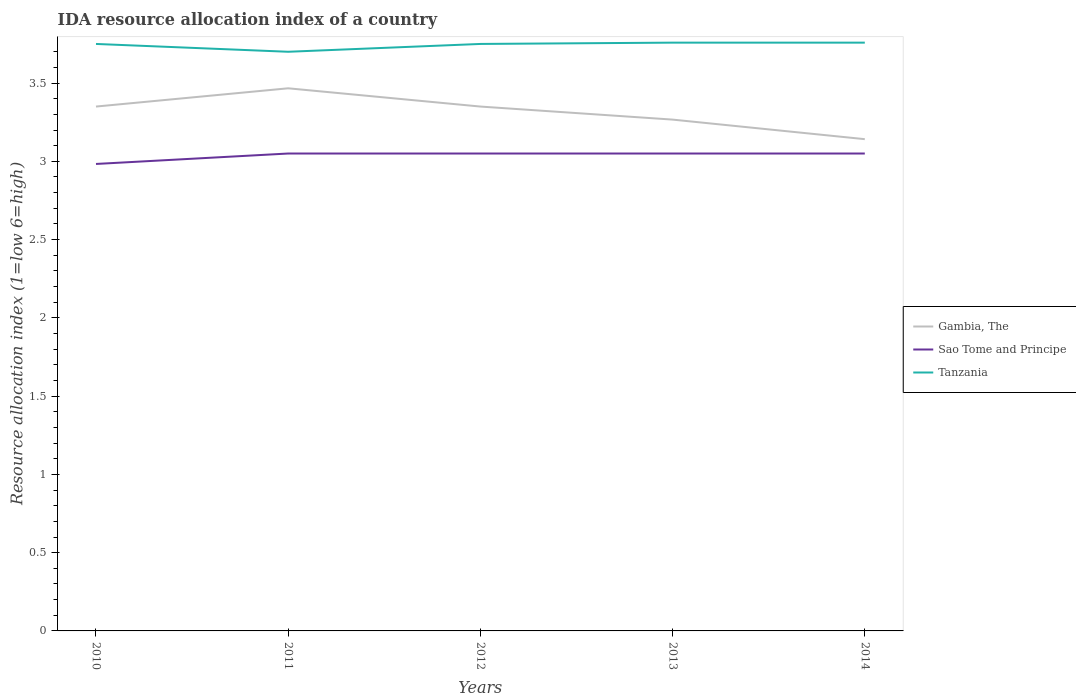How many different coloured lines are there?
Give a very brief answer. 3. Does the line corresponding to Tanzania intersect with the line corresponding to Gambia, The?
Your response must be concise. No. Is the number of lines equal to the number of legend labels?
Your answer should be compact. Yes. Across all years, what is the maximum IDA resource allocation index in Sao Tome and Principe?
Make the answer very short. 2.98. What is the total IDA resource allocation index in Sao Tome and Principe in the graph?
Ensure brevity in your answer.  -0.07. What is the difference between the highest and the second highest IDA resource allocation index in Sao Tome and Principe?
Provide a succinct answer. 0.07. How many years are there in the graph?
Offer a terse response. 5. Are the values on the major ticks of Y-axis written in scientific E-notation?
Your answer should be very brief. No. Does the graph contain any zero values?
Your answer should be very brief. No. Does the graph contain grids?
Give a very brief answer. No. Where does the legend appear in the graph?
Offer a terse response. Center right. How are the legend labels stacked?
Give a very brief answer. Vertical. What is the title of the graph?
Ensure brevity in your answer.  IDA resource allocation index of a country. Does "South Africa" appear as one of the legend labels in the graph?
Your response must be concise. No. What is the label or title of the X-axis?
Your answer should be compact. Years. What is the label or title of the Y-axis?
Offer a terse response. Resource allocation index (1=low 6=high). What is the Resource allocation index (1=low 6=high) in Gambia, The in 2010?
Give a very brief answer. 3.35. What is the Resource allocation index (1=low 6=high) in Sao Tome and Principe in 2010?
Give a very brief answer. 2.98. What is the Resource allocation index (1=low 6=high) in Tanzania in 2010?
Offer a very short reply. 3.75. What is the Resource allocation index (1=low 6=high) in Gambia, The in 2011?
Your answer should be very brief. 3.47. What is the Resource allocation index (1=low 6=high) in Sao Tome and Principe in 2011?
Your response must be concise. 3.05. What is the Resource allocation index (1=low 6=high) in Gambia, The in 2012?
Offer a very short reply. 3.35. What is the Resource allocation index (1=low 6=high) of Sao Tome and Principe in 2012?
Your answer should be very brief. 3.05. What is the Resource allocation index (1=low 6=high) of Tanzania in 2012?
Make the answer very short. 3.75. What is the Resource allocation index (1=low 6=high) of Gambia, The in 2013?
Your answer should be very brief. 3.27. What is the Resource allocation index (1=low 6=high) in Sao Tome and Principe in 2013?
Your response must be concise. 3.05. What is the Resource allocation index (1=low 6=high) of Tanzania in 2013?
Keep it short and to the point. 3.76. What is the Resource allocation index (1=low 6=high) of Gambia, The in 2014?
Your answer should be compact. 3.14. What is the Resource allocation index (1=low 6=high) in Sao Tome and Principe in 2014?
Keep it short and to the point. 3.05. What is the Resource allocation index (1=low 6=high) of Tanzania in 2014?
Give a very brief answer. 3.76. Across all years, what is the maximum Resource allocation index (1=low 6=high) of Gambia, The?
Offer a very short reply. 3.47. Across all years, what is the maximum Resource allocation index (1=low 6=high) of Sao Tome and Principe?
Ensure brevity in your answer.  3.05. Across all years, what is the maximum Resource allocation index (1=low 6=high) in Tanzania?
Your response must be concise. 3.76. Across all years, what is the minimum Resource allocation index (1=low 6=high) of Gambia, The?
Your answer should be very brief. 3.14. Across all years, what is the minimum Resource allocation index (1=low 6=high) in Sao Tome and Principe?
Provide a short and direct response. 2.98. Across all years, what is the minimum Resource allocation index (1=low 6=high) of Tanzania?
Offer a very short reply. 3.7. What is the total Resource allocation index (1=low 6=high) of Gambia, The in the graph?
Your response must be concise. 16.57. What is the total Resource allocation index (1=low 6=high) in Sao Tome and Principe in the graph?
Provide a succinct answer. 15.18. What is the total Resource allocation index (1=low 6=high) in Tanzania in the graph?
Your answer should be compact. 18.72. What is the difference between the Resource allocation index (1=low 6=high) in Gambia, The in 2010 and that in 2011?
Give a very brief answer. -0.12. What is the difference between the Resource allocation index (1=low 6=high) of Sao Tome and Principe in 2010 and that in 2011?
Offer a very short reply. -0.07. What is the difference between the Resource allocation index (1=low 6=high) of Tanzania in 2010 and that in 2011?
Your answer should be compact. 0.05. What is the difference between the Resource allocation index (1=low 6=high) of Gambia, The in 2010 and that in 2012?
Provide a short and direct response. 0. What is the difference between the Resource allocation index (1=low 6=high) of Sao Tome and Principe in 2010 and that in 2012?
Offer a terse response. -0.07. What is the difference between the Resource allocation index (1=low 6=high) in Tanzania in 2010 and that in 2012?
Offer a terse response. 0. What is the difference between the Resource allocation index (1=low 6=high) of Gambia, The in 2010 and that in 2013?
Ensure brevity in your answer.  0.08. What is the difference between the Resource allocation index (1=low 6=high) in Sao Tome and Principe in 2010 and that in 2013?
Your answer should be compact. -0.07. What is the difference between the Resource allocation index (1=low 6=high) of Tanzania in 2010 and that in 2013?
Your answer should be compact. -0.01. What is the difference between the Resource allocation index (1=low 6=high) of Gambia, The in 2010 and that in 2014?
Provide a succinct answer. 0.21. What is the difference between the Resource allocation index (1=low 6=high) of Sao Tome and Principe in 2010 and that in 2014?
Provide a short and direct response. -0.07. What is the difference between the Resource allocation index (1=low 6=high) of Tanzania in 2010 and that in 2014?
Your answer should be compact. -0.01. What is the difference between the Resource allocation index (1=low 6=high) of Gambia, The in 2011 and that in 2012?
Ensure brevity in your answer.  0.12. What is the difference between the Resource allocation index (1=low 6=high) in Tanzania in 2011 and that in 2012?
Ensure brevity in your answer.  -0.05. What is the difference between the Resource allocation index (1=low 6=high) of Gambia, The in 2011 and that in 2013?
Your answer should be compact. 0.2. What is the difference between the Resource allocation index (1=low 6=high) of Tanzania in 2011 and that in 2013?
Make the answer very short. -0.06. What is the difference between the Resource allocation index (1=low 6=high) in Gambia, The in 2011 and that in 2014?
Your answer should be compact. 0.33. What is the difference between the Resource allocation index (1=low 6=high) of Sao Tome and Principe in 2011 and that in 2014?
Offer a terse response. 0. What is the difference between the Resource allocation index (1=low 6=high) of Tanzania in 2011 and that in 2014?
Provide a succinct answer. -0.06. What is the difference between the Resource allocation index (1=low 6=high) in Gambia, The in 2012 and that in 2013?
Offer a terse response. 0.08. What is the difference between the Resource allocation index (1=low 6=high) of Tanzania in 2012 and that in 2013?
Your answer should be compact. -0.01. What is the difference between the Resource allocation index (1=low 6=high) of Gambia, The in 2012 and that in 2014?
Make the answer very short. 0.21. What is the difference between the Resource allocation index (1=low 6=high) of Tanzania in 2012 and that in 2014?
Offer a very short reply. -0.01. What is the difference between the Resource allocation index (1=low 6=high) of Gambia, The in 2013 and that in 2014?
Offer a terse response. 0.12. What is the difference between the Resource allocation index (1=low 6=high) in Sao Tome and Principe in 2013 and that in 2014?
Make the answer very short. 0. What is the difference between the Resource allocation index (1=low 6=high) in Tanzania in 2013 and that in 2014?
Your answer should be compact. 0. What is the difference between the Resource allocation index (1=low 6=high) of Gambia, The in 2010 and the Resource allocation index (1=low 6=high) of Tanzania in 2011?
Make the answer very short. -0.35. What is the difference between the Resource allocation index (1=low 6=high) of Sao Tome and Principe in 2010 and the Resource allocation index (1=low 6=high) of Tanzania in 2011?
Offer a terse response. -0.72. What is the difference between the Resource allocation index (1=low 6=high) of Sao Tome and Principe in 2010 and the Resource allocation index (1=low 6=high) of Tanzania in 2012?
Provide a short and direct response. -0.77. What is the difference between the Resource allocation index (1=low 6=high) in Gambia, The in 2010 and the Resource allocation index (1=low 6=high) in Tanzania in 2013?
Keep it short and to the point. -0.41. What is the difference between the Resource allocation index (1=low 6=high) of Sao Tome and Principe in 2010 and the Resource allocation index (1=low 6=high) of Tanzania in 2013?
Offer a terse response. -0.78. What is the difference between the Resource allocation index (1=low 6=high) of Gambia, The in 2010 and the Resource allocation index (1=low 6=high) of Tanzania in 2014?
Your answer should be very brief. -0.41. What is the difference between the Resource allocation index (1=low 6=high) in Sao Tome and Principe in 2010 and the Resource allocation index (1=low 6=high) in Tanzania in 2014?
Keep it short and to the point. -0.78. What is the difference between the Resource allocation index (1=low 6=high) of Gambia, The in 2011 and the Resource allocation index (1=low 6=high) of Sao Tome and Principe in 2012?
Provide a succinct answer. 0.42. What is the difference between the Resource allocation index (1=low 6=high) of Gambia, The in 2011 and the Resource allocation index (1=low 6=high) of Tanzania in 2012?
Provide a short and direct response. -0.28. What is the difference between the Resource allocation index (1=low 6=high) of Sao Tome and Principe in 2011 and the Resource allocation index (1=low 6=high) of Tanzania in 2012?
Offer a terse response. -0.7. What is the difference between the Resource allocation index (1=low 6=high) of Gambia, The in 2011 and the Resource allocation index (1=low 6=high) of Sao Tome and Principe in 2013?
Give a very brief answer. 0.42. What is the difference between the Resource allocation index (1=low 6=high) in Gambia, The in 2011 and the Resource allocation index (1=low 6=high) in Tanzania in 2013?
Ensure brevity in your answer.  -0.29. What is the difference between the Resource allocation index (1=low 6=high) in Sao Tome and Principe in 2011 and the Resource allocation index (1=low 6=high) in Tanzania in 2013?
Keep it short and to the point. -0.71. What is the difference between the Resource allocation index (1=low 6=high) of Gambia, The in 2011 and the Resource allocation index (1=low 6=high) of Sao Tome and Principe in 2014?
Your response must be concise. 0.42. What is the difference between the Resource allocation index (1=low 6=high) of Gambia, The in 2011 and the Resource allocation index (1=low 6=high) of Tanzania in 2014?
Keep it short and to the point. -0.29. What is the difference between the Resource allocation index (1=low 6=high) of Sao Tome and Principe in 2011 and the Resource allocation index (1=low 6=high) of Tanzania in 2014?
Provide a succinct answer. -0.71. What is the difference between the Resource allocation index (1=low 6=high) in Gambia, The in 2012 and the Resource allocation index (1=low 6=high) in Tanzania in 2013?
Make the answer very short. -0.41. What is the difference between the Resource allocation index (1=low 6=high) of Sao Tome and Principe in 2012 and the Resource allocation index (1=low 6=high) of Tanzania in 2013?
Your answer should be very brief. -0.71. What is the difference between the Resource allocation index (1=low 6=high) of Gambia, The in 2012 and the Resource allocation index (1=low 6=high) of Tanzania in 2014?
Your answer should be very brief. -0.41. What is the difference between the Resource allocation index (1=low 6=high) in Sao Tome and Principe in 2012 and the Resource allocation index (1=low 6=high) in Tanzania in 2014?
Your answer should be very brief. -0.71. What is the difference between the Resource allocation index (1=low 6=high) of Gambia, The in 2013 and the Resource allocation index (1=low 6=high) of Sao Tome and Principe in 2014?
Your answer should be compact. 0.22. What is the difference between the Resource allocation index (1=low 6=high) of Gambia, The in 2013 and the Resource allocation index (1=low 6=high) of Tanzania in 2014?
Your answer should be very brief. -0.49. What is the difference between the Resource allocation index (1=low 6=high) of Sao Tome and Principe in 2013 and the Resource allocation index (1=low 6=high) of Tanzania in 2014?
Your answer should be compact. -0.71. What is the average Resource allocation index (1=low 6=high) of Gambia, The per year?
Your answer should be compact. 3.31. What is the average Resource allocation index (1=low 6=high) in Sao Tome and Principe per year?
Offer a terse response. 3.04. What is the average Resource allocation index (1=low 6=high) of Tanzania per year?
Offer a very short reply. 3.74. In the year 2010, what is the difference between the Resource allocation index (1=low 6=high) in Gambia, The and Resource allocation index (1=low 6=high) in Sao Tome and Principe?
Provide a succinct answer. 0.37. In the year 2010, what is the difference between the Resource allocation index (1=low 6=high) in Gambia, The and Resource allocation index (1=low 6=high) in Tanzania?
Provide a succinct answer. -0.4. In the year 2010, what is the difference between the Resource allocation index (1=low 6=high) of Sao Tome and Principe and Resource allocation index (1=low 6=high) of Tanzania?
Offer a very short reply. -0.77. In the year 2011, what is the difference between the Resource allocation index (1=low 6=high) in Gambia, The and Resource allocation index (1=low 6=high) in Sao Tome and Principe?
Make the answer very short. 0.42. In the year 2011, what is the difference between the Resource allocation index (1=low 6=high) in Gambia, The and Resource allocation index (1=low 6=high) in Tanzania?
Your response must be concise. -0.23. In the year 2011, what is the difference between the Resource allocation index (1=low 6=high) of Sao Tome and Principe and Resource allocation index (1=low 6=high) of Tanzania?
Offer a very short reply. -0.65. In the year 2012, what is the difference between the Resource allocation index (1=low 6=high) of Gambia, The and Resource allocation index (1=low 6=high) of Tanzania?
Ensure brevity in your answer.  -0.4. In the year 2012, what is the difference between the Resource allocation index (1=low 6=high) of Sao Tome and Principe and Resource allocation index (1=low 6=high) of Tanzania?
Provide a succinct answer. -0.7. In the year 2013, what is the difference between the Resource allocation index (1=low 6=high) in Gambia, The and Resource allocation index (1=low 6=high) in Sao Tome and Principe?
Your response must be concise. 0.22. In the year 2013, what is the difference between the Resource allocation index (1=low 6=high) in Gambia, The and Resource allocation index (1=low 6=high) in Tanzania?
Offer a terse response. -0.49. In the year 2013, what is the difference between the Resource allocation index (1=low 6=high) of Sao Tome and Principe and Resource allocation index (1=low 6=high) of Tanzania?
Your response must be concise. -0.71. In the year 2014, what is the difference between the Resource allocation index (1=low 6=high) of Gambia, The and Resource allocation index (1=low 6=high) of Sao Tome and Principe?
Make the answer very short. 0.09. In the year 2014, what is the difference between the Resource allocation index (1=low 6=high) in Gambia, The and Resource allocation index (1=low 6=high) in Tanzania?
Provide a succinct answer. -0.62. In the year 2014, what is the difference between the Resource allocation index (1=low 6=high) of Sao Tome and Principe and Resource allocation index (1=low 6=high) of Tanzania?
Offer a terse response. -0.71. What is the ratio of the Resource allocation index (1=low 6=high) in Gambia, The in 2010 to that in 2011?
Your response must be concise. 0.97. What is the ratio of the Resource allocation index (1=low 6=high) of Sao Tome and Principe in 2010 to that in 2011?
Your answer should be compact. 0.98. What is the ratio of the Resource allocation index (1=low 6=high) in Tanzania in 2010 to that in 2011?
Offer a terse response. 1.01. What is the ratio of the Resource allocation index (1=low 6=high) of Gambia, The in 2010 to that in 2012?
Your response must be concise. 1. What is the ratio of the Resource allocation index (1=low 6=high) of Sao Tome and Principe in 2010 to that in 2012?
Offer a terse response. 0.98. What is the ratio of the Resource allocation index (1=low 6=high) in Tanzania in 2010 to that in 2012?
Your answer should be compact. 1. What is the ratio of the Resource allocation index (1=low 6=high) of Gambia, The in 2010 to that in 2013?
Give a very brief answer. 1.03. What is the ratio of the Resource allocation index (1=low 6=high) of Sao Tome and Principe in 2010 to that in 2013?
Keep it short and to the point. 0.98. What is the ratio of the Resource allocation index (1=low 6=high) of Gambia, The in 2010 to that in 2014?
Provide a succinct answer. 1.07. What is the ratio of the Resource allocation index (1=low 6=high) in Sao Tome and Principe in 2010 to that in 2014?
Offer a very short reply. 0.98. What is the ratio of the Resource allocation index (1=low 6=high) in Tanzania in 2010 to that in 2014?
Give a very brief answer. 1. What is the ratio of the Resource allocation index (1=low 6=high) in Gambia, The in 2011 to that in 2012?
Give a very brief answer. 1.03. What is the ratio of the Resource allocation index (1=low 6=high) of Sao Tome and Principe in 2011 to that in 2012?
Offer a terse response. 1. What is the ratio of the Resource allocation index (1=low 6=high) in Tanzania in 2011 to that in 2012?
Keep it short and to the point. 0.99. What is the ratio of the Resource allocation index (1=low 6=high) in Gambia, The in 2011 to that in 2013?
Provide a succinct answer. 1.06. What is the ratio of the Resource allocation index (1=low 6=high) of Tanzania in 2011 to that in 2013?
Keep it short and to the point. 0.98. What is the ratio of the Resource allocation index (1=low 6=high) of Gambia, The in 2011 to that in 2014?
Make the answer very short. 1.1. What is the ratio of the Resource allocation index (1=low 6=high) in Sao Tome and Principe in 2011 to that in 2014?
Provide a short and direct response. 1. What is the ratio of the Resource allocation index (1=low 6=high) in Tanzania in 2011 to that in 2014?
Make the answer very short. 0.98. What is the ratio of the Resource allocation index (1=low 6=high) in Gambia, The in 2012 to that in 2013?
Your answer should be compact. 1.03. What is the ratio of the Resource allocation index (1=low 6=high) in Sao Tome and Principe in 2012 to that in 2013?
Give a very brief answer. 1. What is the ratio of the Resource allocation index (1=low 6=high) of Gambia, The in 2012 to that in 2014?
Provide a short and direct response. 1.07. What is the ratio of the Resource allocation index (1=low 6=high) of Sao Tome and Principe in 2012 to that in 2014?
Your answer should be very brief. 1. What is the ratio of the Resource allocation index (1=low 6=high) of Tanzania in 2012 to that in 2014?
Offer a very short reply. 1. What is the ratio of the Resource allocation index (1=low 6=high) in Gambia, The in 2013 to that in 2014?
Offer a terse response. 1.04. What is the ratio of the Resource allocation index (1=low 6=high) of Sao Tome and Principe in 2013 to that in 2014?
Your answer should be very brief. 1. What is the difference between the highest and the second highest Resource allocation index (1=low 6=high) in Gambia, The?
Offer a terse response. 0.12. What is the difference between the highest and the second highest Resource allocation index (1=low 6=high) in Tanzania?
Provide a succinct answer. 0. What is the difference between the highest and the lowest Resource allocation index (1=low 6=high) of Gambia, The?
Ensure brevity in your answer.  0.33. What is the difference between the highest and the lowest Resource allocation index (1=low 6=high) of Sao Tome and Principe?
Provide a succinct answer. 0.07. What is the difference between the highest and the lowest Resource allocation index (1=low 6=high) of Tanzania?
Keep it short and to the point. 0.06. 